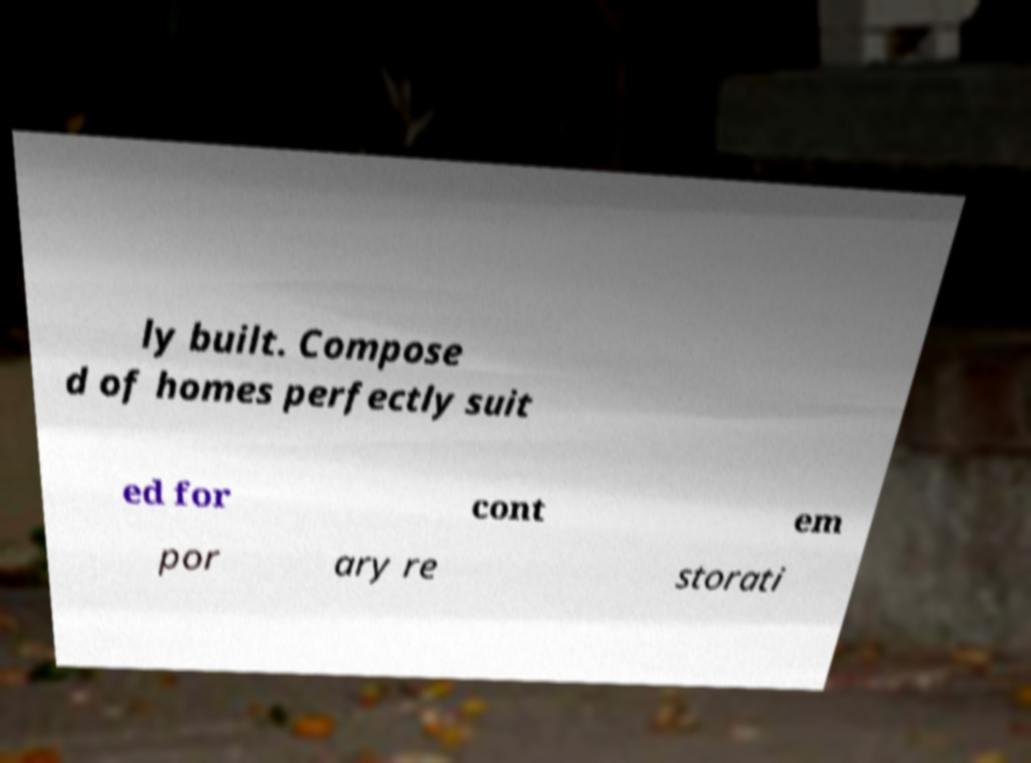What messages or text are displayed in this image? I need them in a readable, typed format. ly built. Compose d of homes perfectly suit ed for cont em por ary re storati 